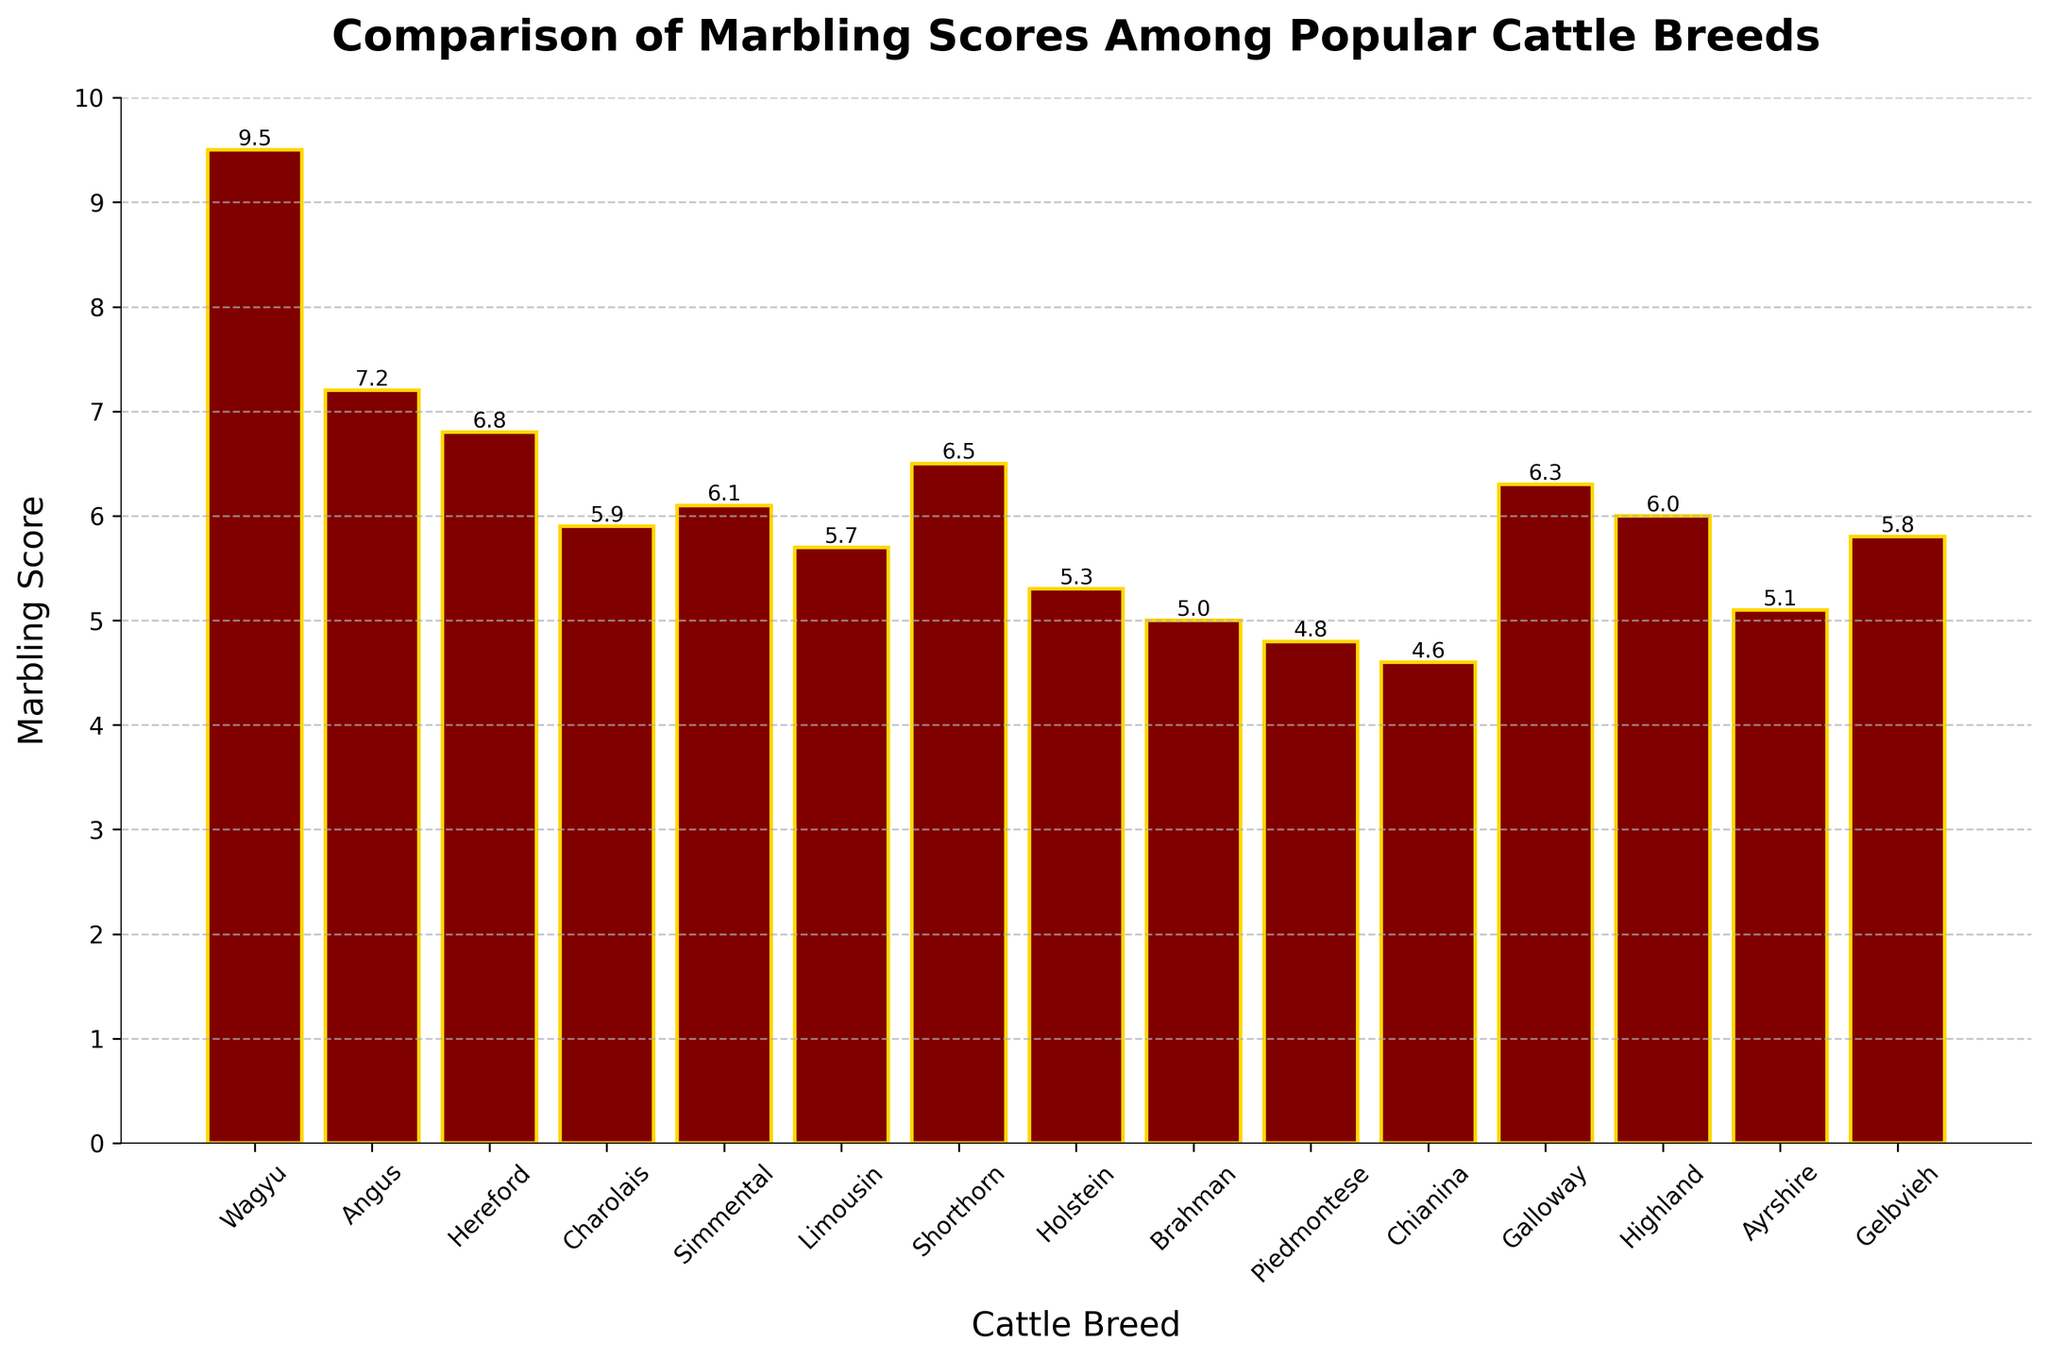Which breed has the highest marbling score? The bar with the greatest height corresponds to the breed with the highest marbling score. The Wagyu breed has the tallest bar.
Answer: Wagyu What is the difference in marbling scores between Wagyu and Piedmontese? Locate the heights of the bars for Wagyu and Piedmontese: Wagyu is at 9.5 and Piedmontese is at 4.8. Subtract Piedmontese's score from Wagyu's: 9.5 - 4.8 = 4.7.
Answer: 4.7 Among Angus, Hereford, and Limousin, which breed has the highest marbling score? Look at the bars for Angus, Hereford, and Limousin. Angus is at 7.2, Hereford is at 6.8, and Limousin is at 5.7. The highest score among these is for Angus.
Answer: Angus What is the average marbling score of Simmental, Holstein, and Highland? Find the scores for Simmental (6.1), Holstein (5.3), and Highland (6.0). Add the scores together: 6.1 + 5.3 + 6.0 = 17.4. Divide by the number of scores, which is 3: 17.4 / 3 = 5.8.
Answer: 5.8 Do Galloway and Shorthorn have the same marbling score? Compare the heights of the bars for Galloway and Shorthorn. Galloway has a score of 6.3, while Shorthorn has a score of 6.5. They do not have the same score.
Answer: No What is the median marbling score for the breeds listed? Arrange the scores in ascending order and find the middle value. Sorted scores: 4.6, 4.8, 5.0, 5.1, 5.3, 5.7, 5.8, 5.9, 6.0, 6.1, 6.3, 6.5, 6.8, 7.2, 9.5. The middle value is the 8th one: 5.9.
Answer: 5.9 How many breeds have a marbling score above 6.0? Count the breeds with scores above 6.0 by observing the heights of the bars. Breeds are: Wagyu, Angus, Hereford, Simmental, Shorthorn, Galloway. Total: 6 breeds.
Answer: 6 Which breed has the lowest marbling score? Find the shortest bar, which corresponds to Chianina with a score of 4.6.
Answer: Chianina Is the marbling score of Highland higher than Ayrshire? Observe the heights of the bars for Highland and Ayrshire. Highland's score is 6.0, and Ayrshire's score is 5.1. Highland's score is indeed higher.
Answer: Yes What is the sum of marbling scores for Charolais, Holstein, and Brahman? Find the scores for Charolais (5.9), Holstein (5.3), and Brahman (5.0). Sum these scores: 5.9 + 5.3 + 5.0 = 16.2.
Answer: 16.2 